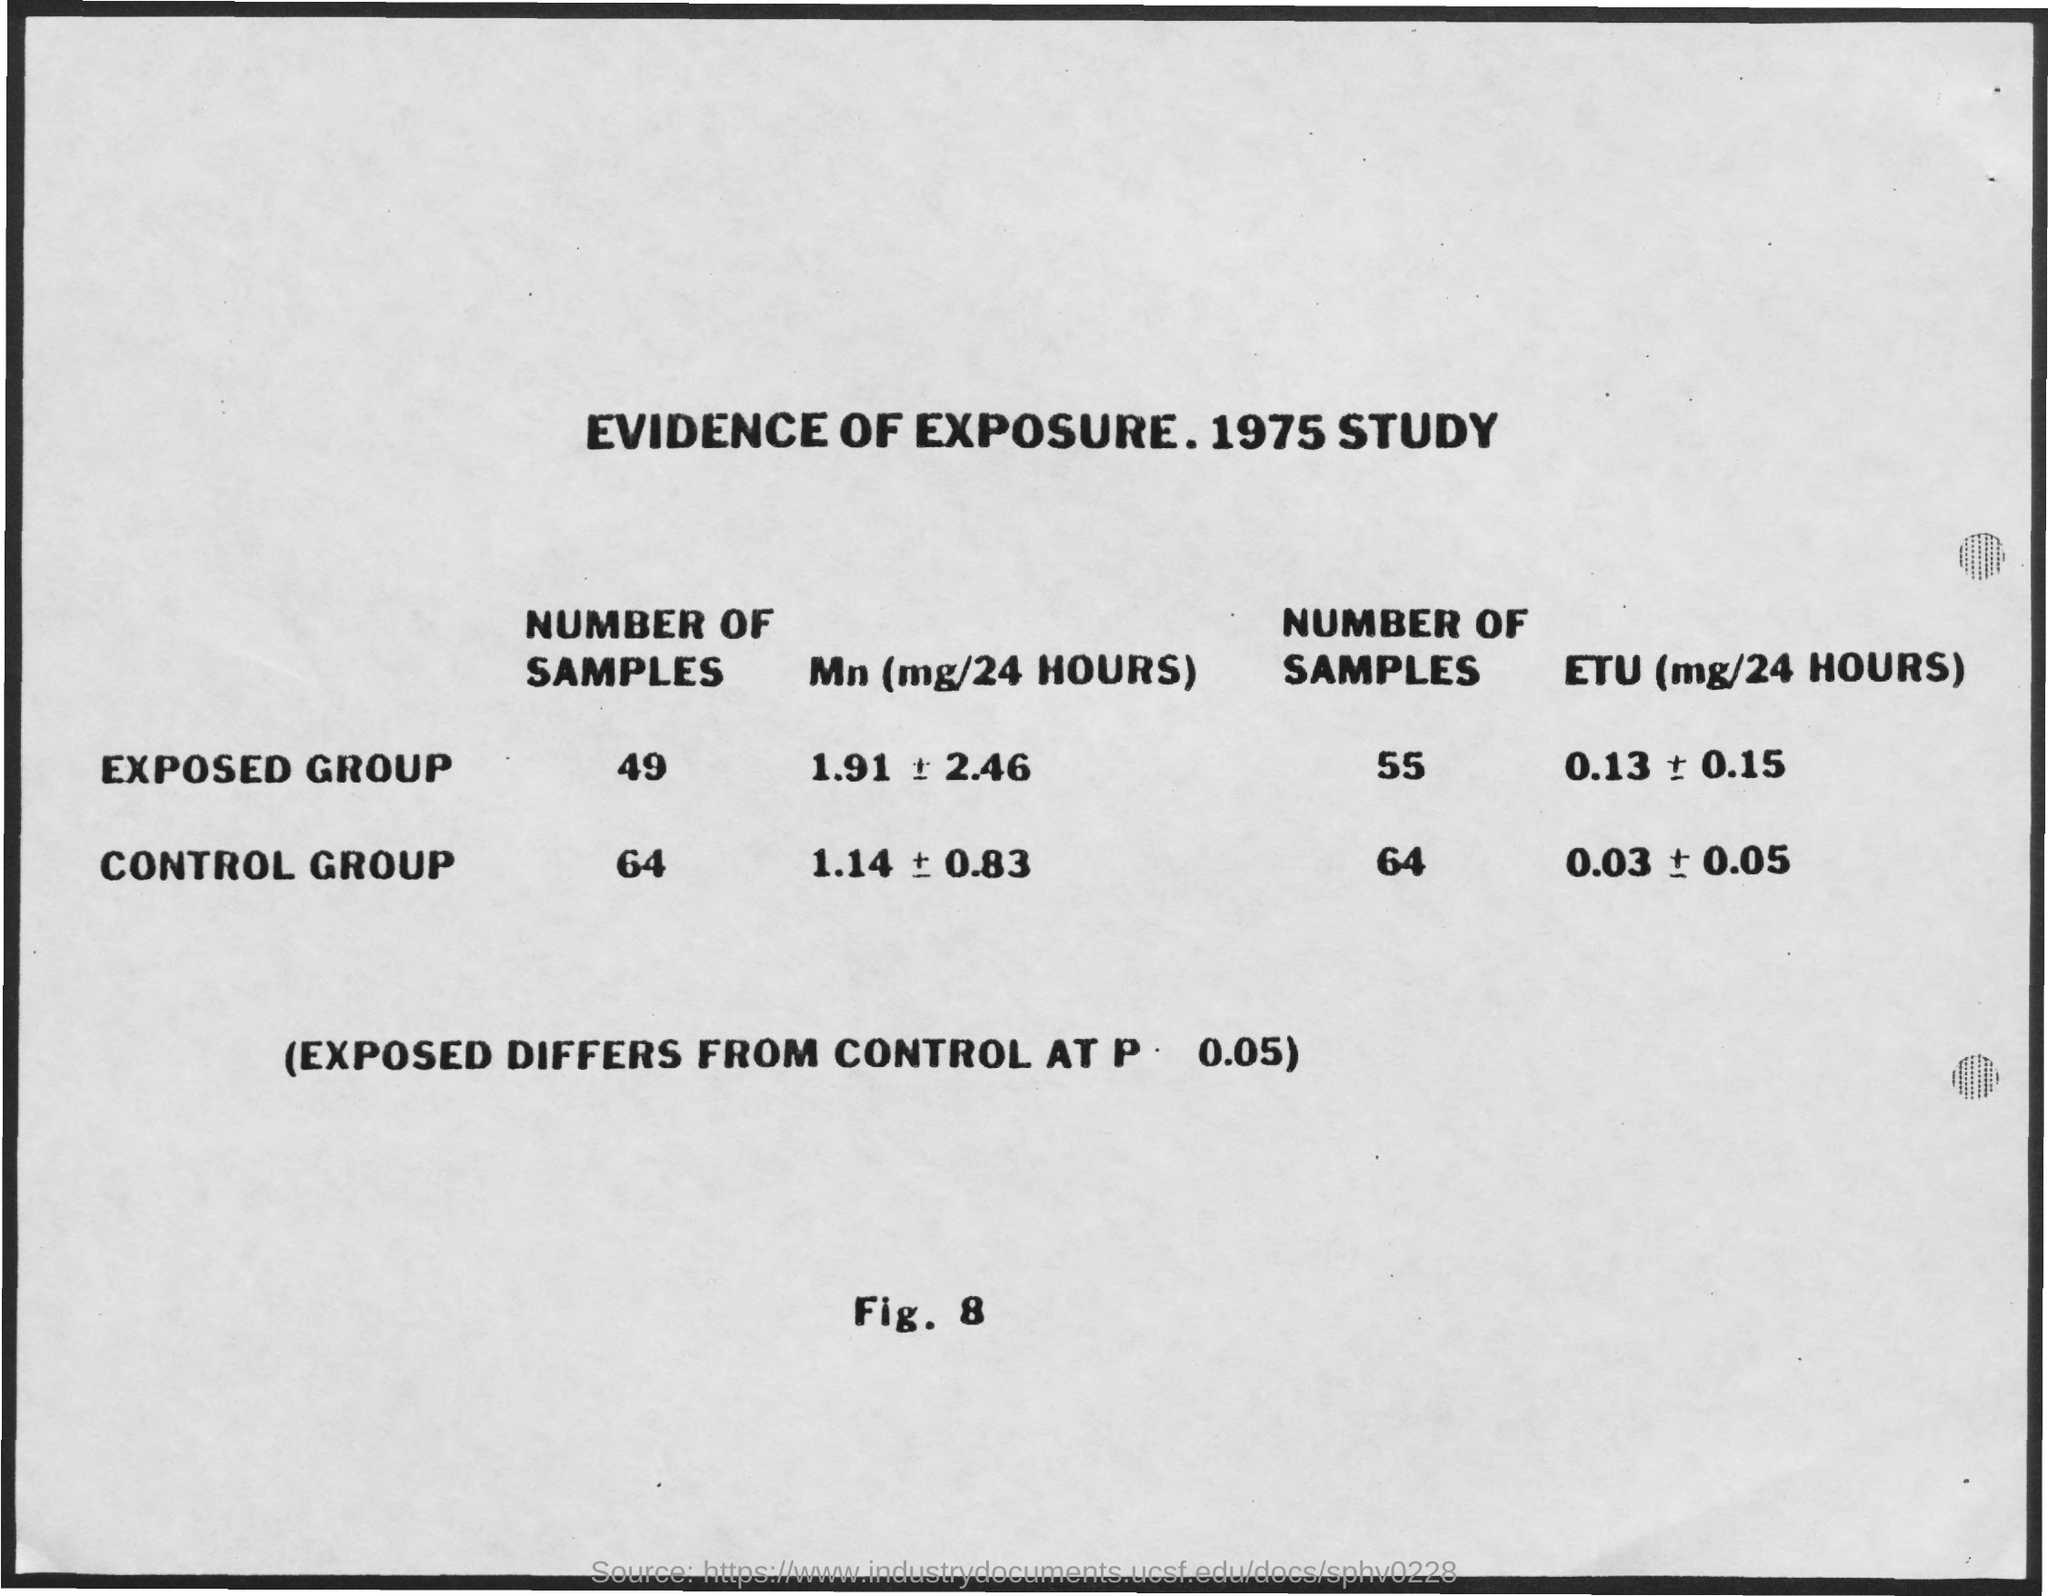What is the title of the page?
Offer a very short reply. Evidence of Exposure. 1975 Study. 